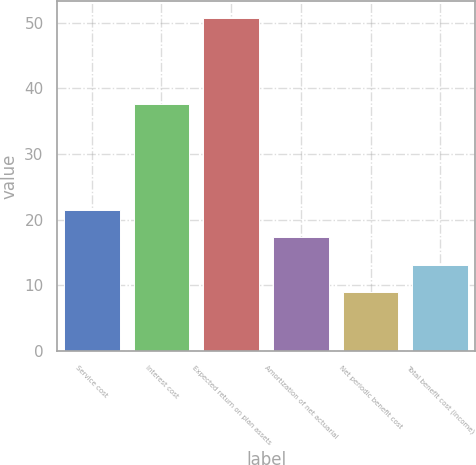Convert chart. <chart><loc_0><loc_0><loc_500><loc_500><bar_chart><fcel>Service cost<fcel>Interest cost<fcel>Expected return on plan assets<fcel>Amortization of net actuarial<fcel>Net periodic benefit cost<fcel>Total benefit cost (income)<nl><fcel>21.51<fcel>37.6<fcel>50.7<fcel>17.34<fcel>9<fcel>13.17<nl></chart> 